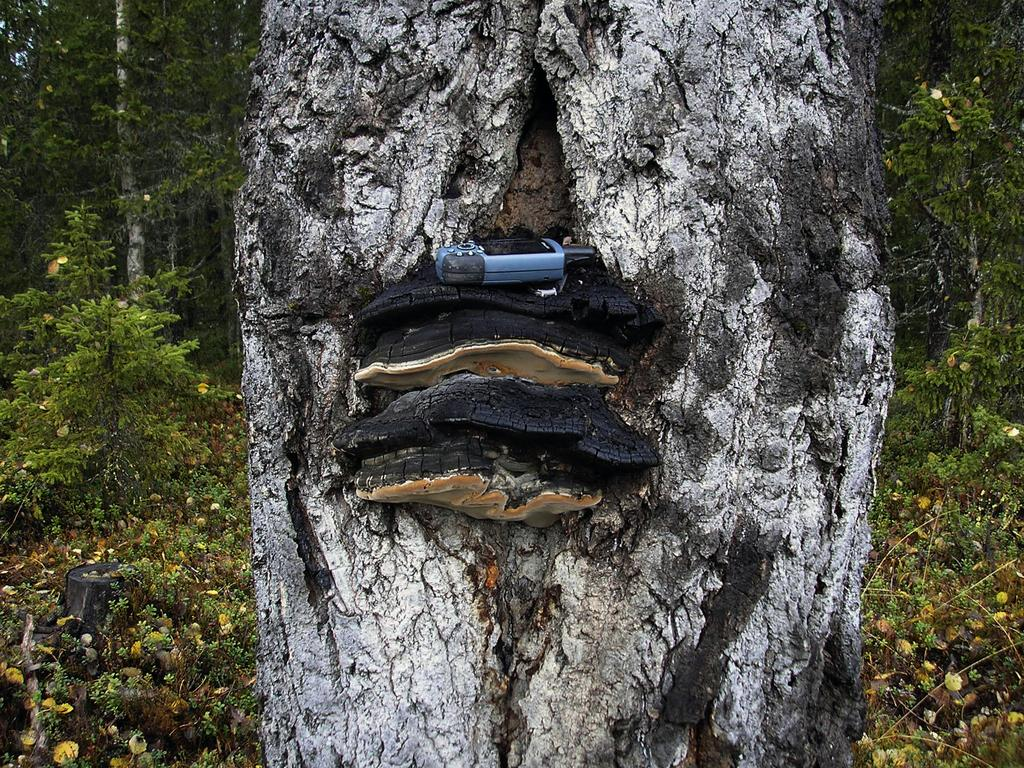What is attached to the tree trunk in the image? There is a device on the tree trunk in the image. What can be seen in the background of the image? There are many trees and plants in the background of the image. How many children are playing near the tree in the image? There is no mention of children in the image; it only features a device on the tree trunk and many trees and plants in the background. 